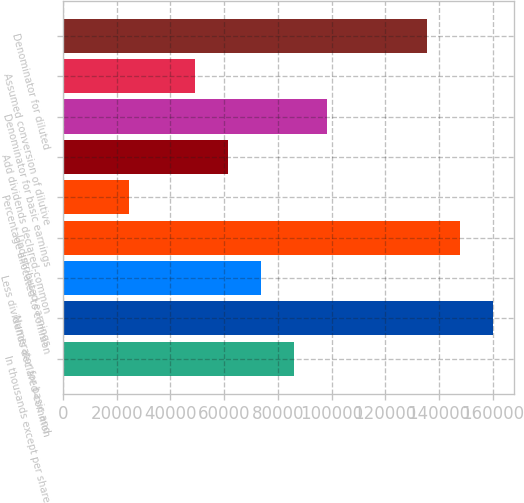Convert chart. <chart><loc_0><loc_0><loc_500><loc_500><bar_chart><fcel>In thousands except per share<fcel>Numerator for basic and<fcel>Less dividends declared-common<fcel>Undistributed earnings<fcel>Percentage allocated to common<fcel>Add dividends declared-common<fcel>Denominator for basic earnings<fcel>Assumed conversion of dilutive<fcel>Denominator for diluted<nl><fcel>86170<fcel>160028<fcel>73860.4<fcel>147718<fcel>24621.8<fcel>61550.8<fcel>98479.7<fcel>49241.1<fcel>135409<nl></chart> 